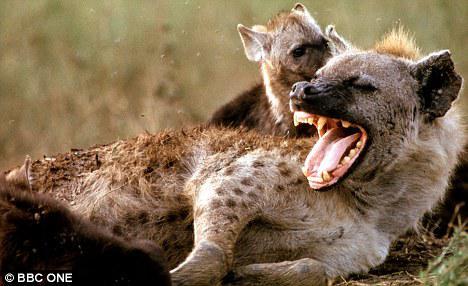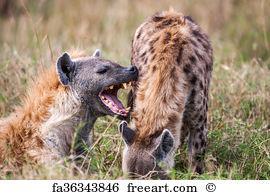The first image is the image on the left, the second image is the image on the right. Considering the images on both sides, is "Two hyenas have their mouths open." valid? Answer yes or no. Yes. The first image is the image on the left, the second image is the image on the right. Assess this claim about the two images: "Each image includes a hyena with a wide open mouth.". Correct or not? Answer yes or no. Yes. 